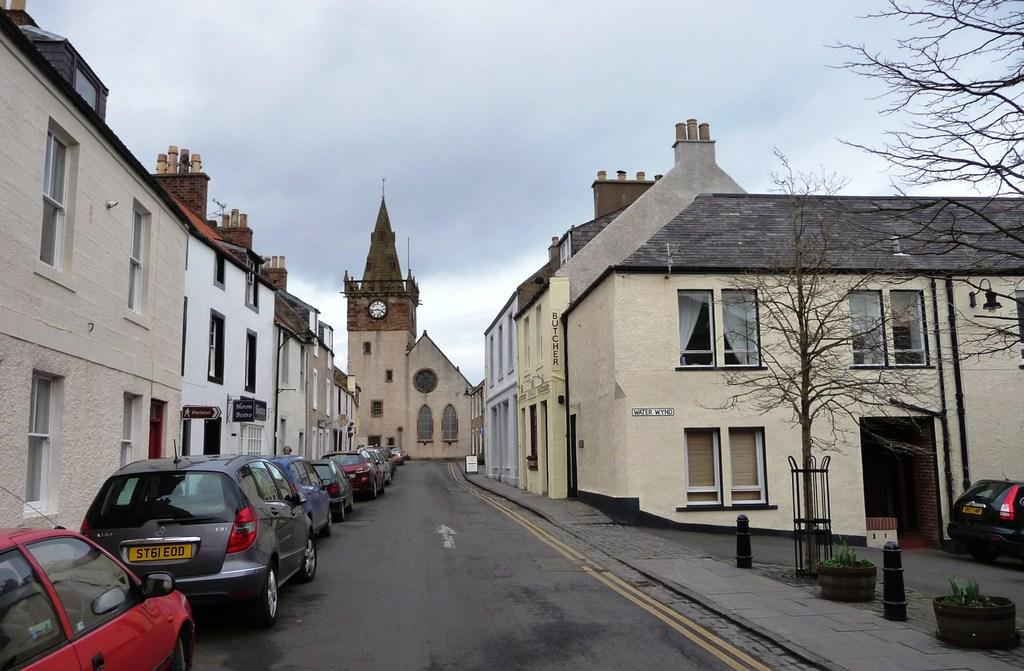What type of structures can be seen in the image? There are buildings in the image. What feature is common among some of the buildings? There are windows in the buildings. What type of vehicles are present in the image? There are cars in the image. What type of vegetation can be seen in the image? There is a plant and trees in the image. What type of lighting is present in the image? There is a street lamp in the image. What part of the natural environment is visible in the image? The sky is visible in the image. What type of whistle can be heard coming from the pig in the image? There is no pig or whistle present in the image. How many bells are hanging from the trees in the image? There are no bells hanging from the trees in the image. 